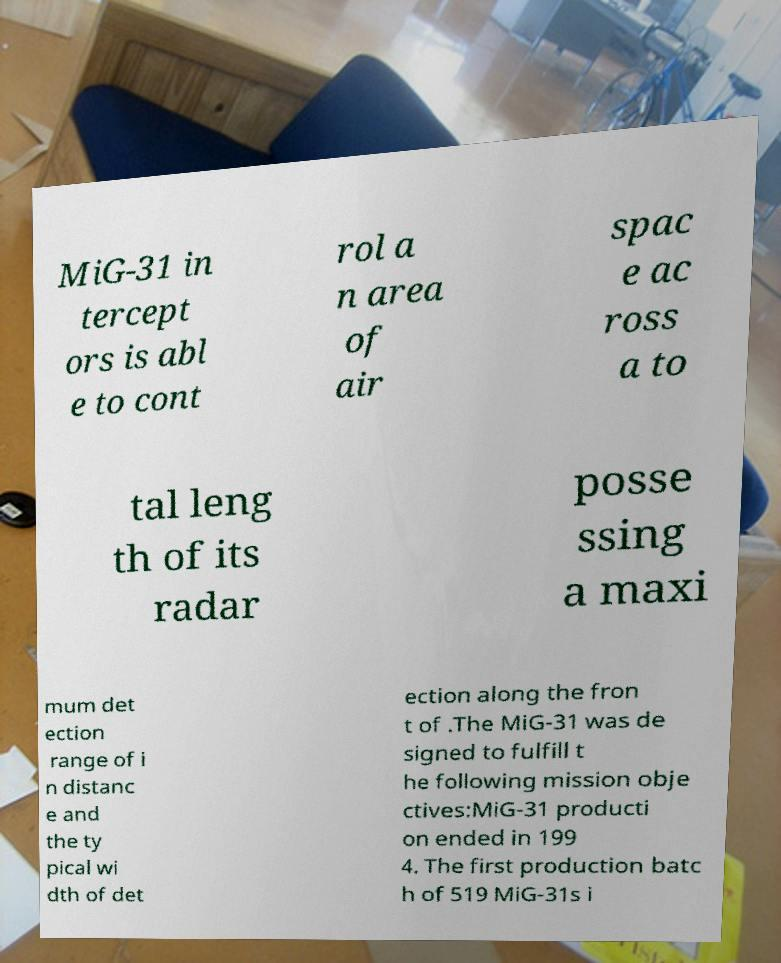Could you extract and type out the text from this image? MiG-31 in tercept ors is abl e to cont rol a n area of air spac e ac ross a to tal leng th of its radar posse ssing a maxi mum det ection range of i n distanc e and the ty pical wi dth of det ection along the fron t of .The MiG-31 was de signed to fulfill t he following mission obje ctives:MiG-31 producti on ended in 199 4. The first production batc h of 519 MiG-31s i 